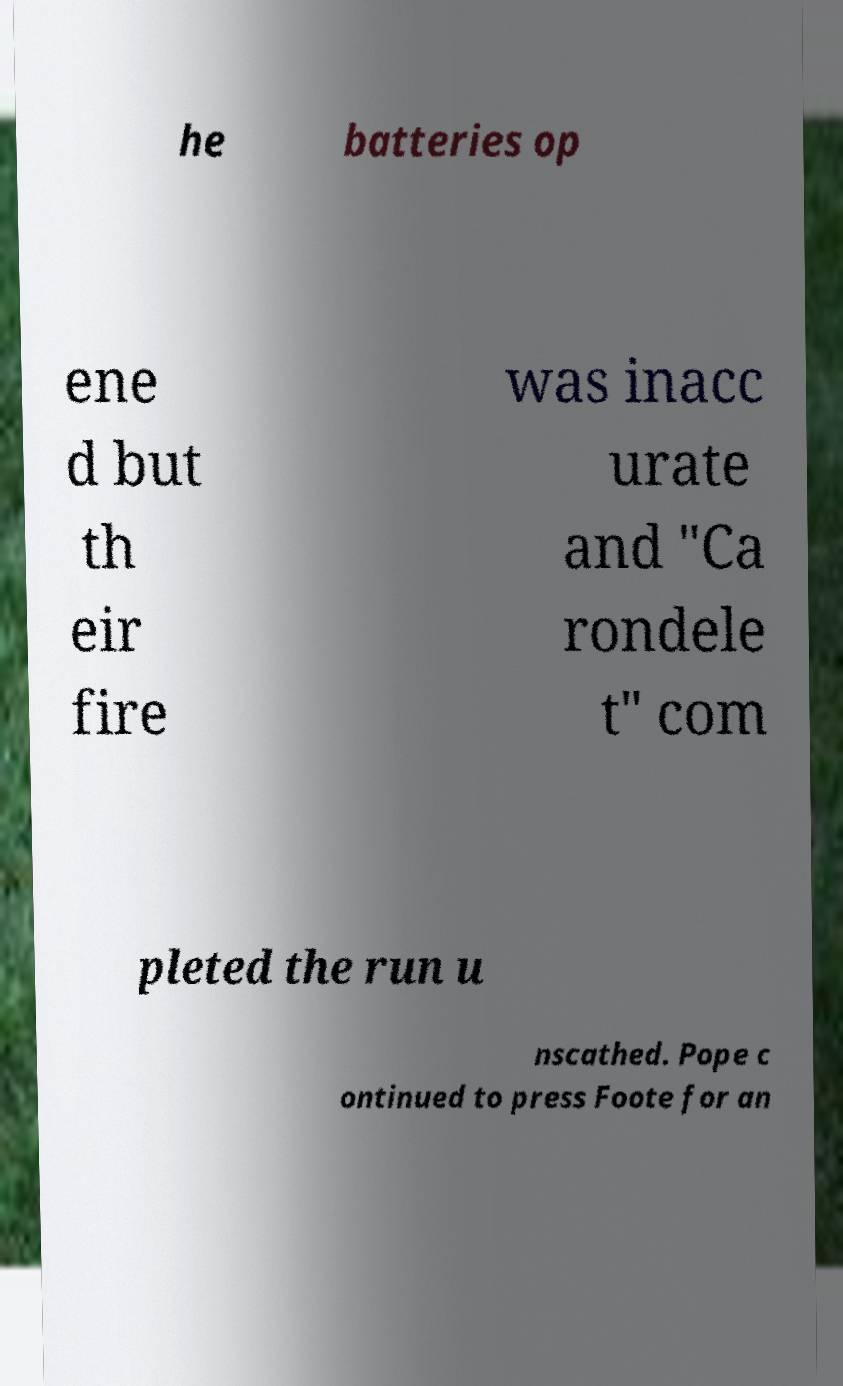Please identify and transcribe the text found in this image. he batteries op ene d but th eir fire was inacc urate and "Ca rondele t" com pleted the run u nscathed. Pope c ontinued to press Foote for an 